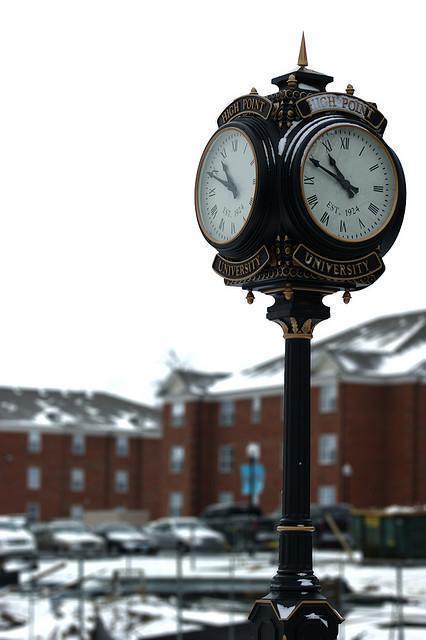This University is affiliated with what denomination?
Indicate the correct response by choosing from the four available options to answer the question.
Options: Baptist, lutheran, mormon, methodist. Methodist. 